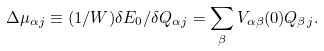Convert formula to latex. <formula><loc_0><loc_0><loc_500><loc_500>\Delta \mu _ { \alpha j } \equiv ( 1 / W ) \delta E _ { 0 } / \delta Q _ { \alpha j } = \sum _ { \beta } V _ { \alpha \beta } ( 0 ) Q _ { \beta j } .</formula> 